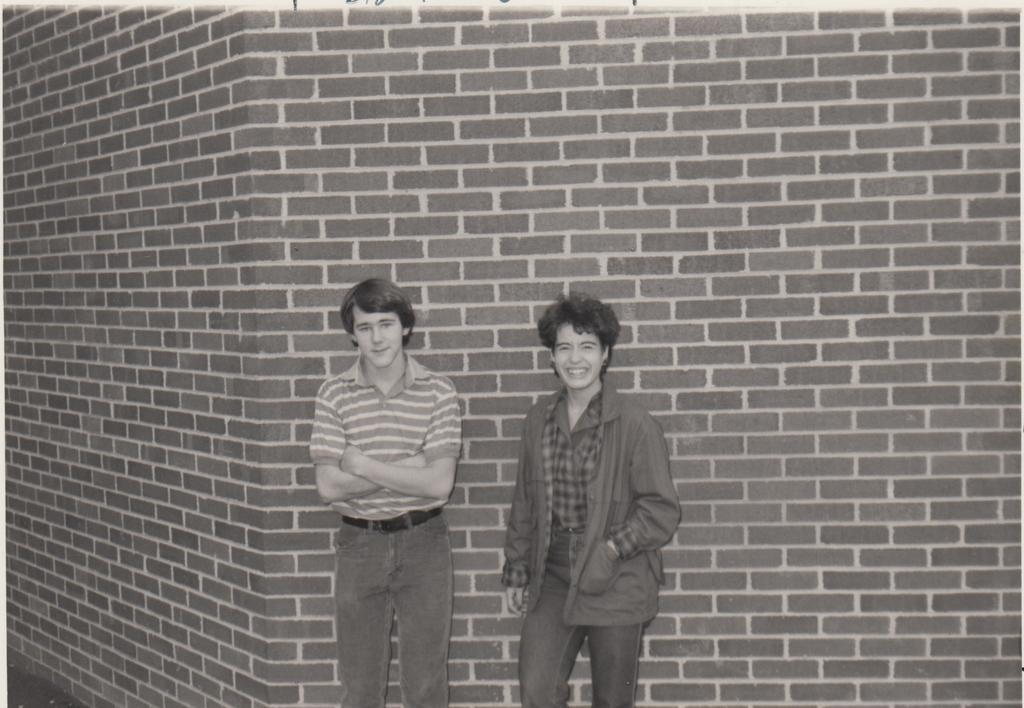How would you summarize this image in a sentence or two? In this image we can see two persons standing and posing for a photograph and in the background of the image there is a brick wall. 